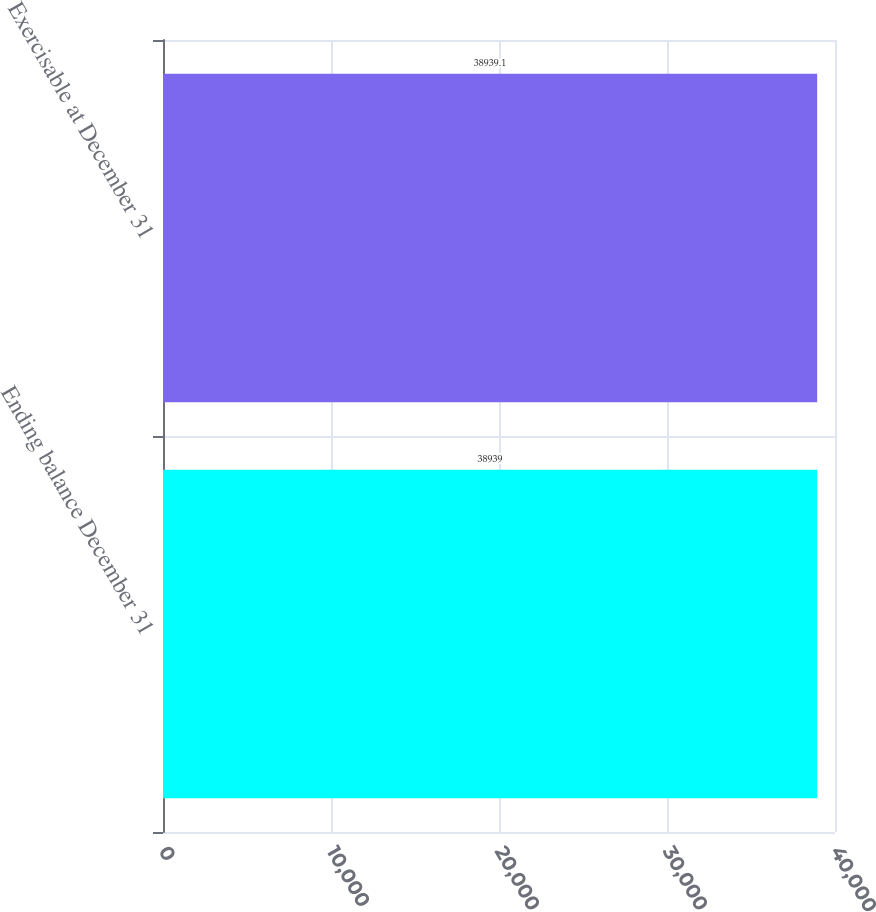Convert chart to OTSL. <chart><loc_0><loc_0><loc_500><loc_500><bar_chart><fcel>Ending balance December 31<fcel>Exercisable at December 31<nl><fcel>38939<fcel>38939.1<nl></chart> 